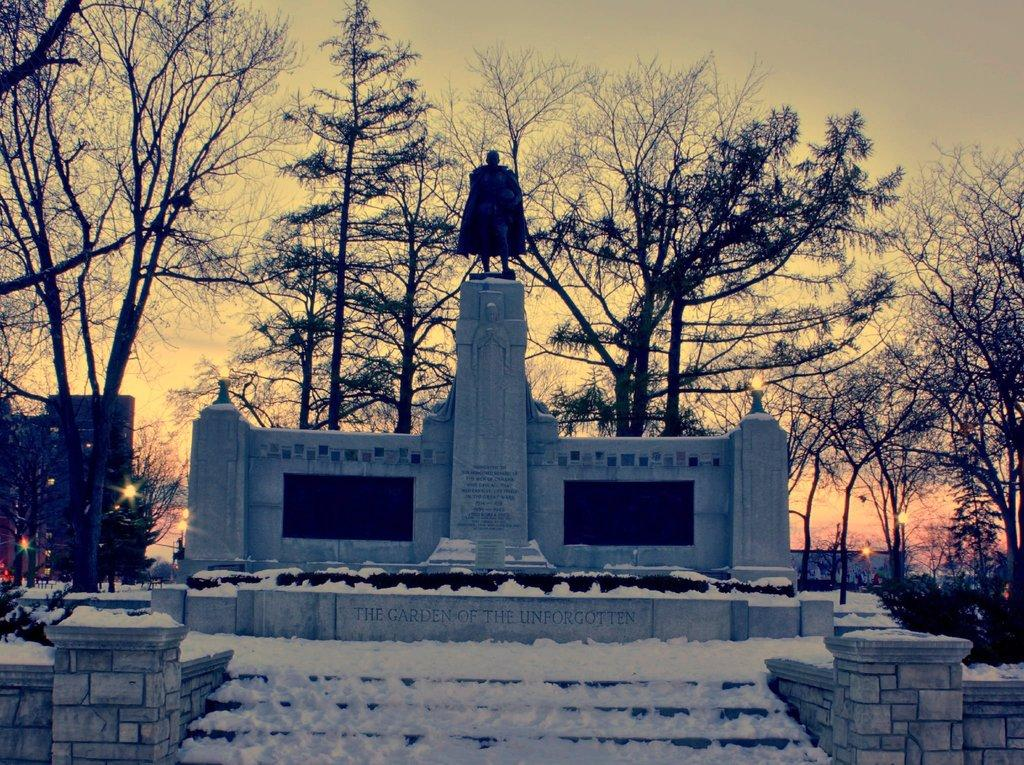What is the main subject of the image? There is a statue in the image. How is the statue positioned in the image? The statue is on a pedestal. What architectural feature can be seen in the image? There are stairs in the image. What is the weather like in the image? There is snow visible in the image, indicating a cold or wintry environment. What type of structures are present in the image? There are buildings in the image. What type of vegetation is present in the image? There are trees in the image. What is visible in the sky in the image? The sky is visible in the image, and the sun is observable. How many deer can be seen grazing near the statue in the image? There are no deer present in the image; it features a statue, snow, buildings, trees, and a visible sky with the sun. What type of bird is perched on the statue's head in the image? There is no bird present on the statue's head in the image. 